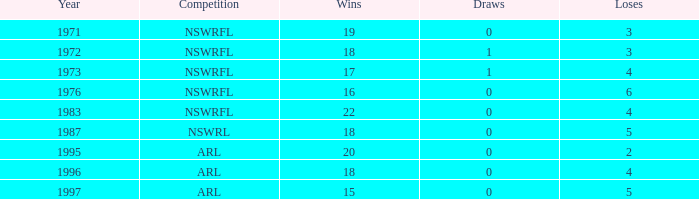Could you parse the entire table? {'header': ['Year', 'Competition', 'Wins', 'Draws', 'Loses'], 'rows': [['1971', 'NSWRFL', '19', '0', '3'], ['1972', 'NSWRFL', '18', '1', '3'], ['1973', 'NSWRFL', '17', '1', '4'], ['1976', 'NSWRFL', '16', '0', '6'], ['1983', 'NSWRFL', '22', '0', '4'], ['1987', 'NSWRL', '18', '0', '5'], ['1995', 'ARL', '20', '0', '2'], ['1996', 'ARL', '18', '0', '4'], ['1997', 'ARL', '15', '0', '5']]} What average Year has Losses 4, and Wins less than 18, and Draws greater than 1? None. 